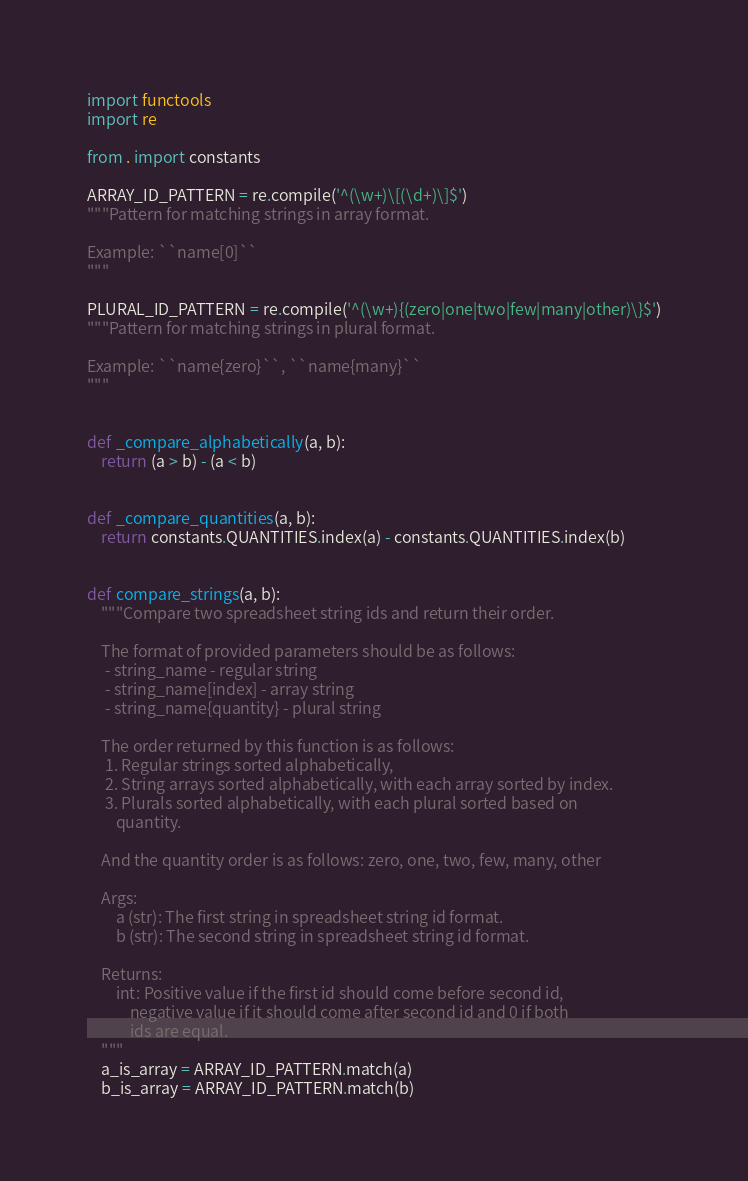<code> <loc_0><loc_0><loc_500><loc_500><_Python_>import functools
import re

from . import constants

ARRAY_ID_PATTERN = re.compile('^(\w+)\[(\d+)\]$')
"""Pattern for matching strings in array format.

Example: ``name[0]``
"""

PLURAL_ID_PATTERN = re.compile('^(\w+){(zero|one|two|few|many|other)\}$')
"""Pattern for matching strings in plural format.

Example: ``name{zero}``, ``name{many}``
"""


def _compare_alphabetically(a, b):
    return (a > b) - (a < b)


def _compare_quantities(a, b):
    return constants.QUANTITIES.index(a) - constants.QUANTITIES.index(b)


def compare_strings(a, b):
    """Compare two spreadsheet string ids and return their order.

    The format of provided parameters should be as follows:
     - string_name - regular string
     - string_name[index] - array string
     - string_name{quantity} - plural string

    The order returned by this function is as follows:
     1. Regular strings sorted alphabetically,
     2. String arrays sorted alphabetically, with each array sorted by index.
     3. Plurals sorted alphabetically, with each plural sorted based on
        quantity.

    And the quantity order is as follows: zero, one, two, few, many, other

    Args:
        a (str): The first string in spreadsheet string id format.
        b (str): The second string in spreadsheet string id format.

    Returns:
        int: Positive value if the first id should come before second id,
            negative value if it should come after second id and 0 if both
            ids are equal.
    """
    a_is_array = ARRAY_ID_PATTERN.match(a)
    b_is_array = ARRAY_ID_PATTERN.match(b)</code> 